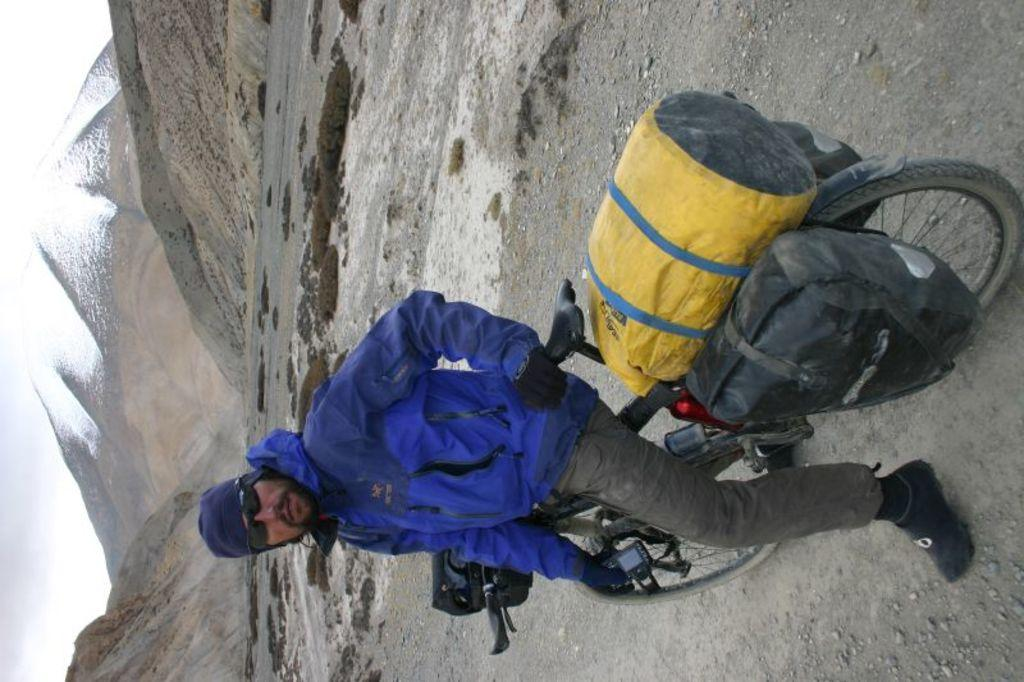Who is in the image? There is a man in the image. What is the man doing in the image? The man is sitting on a bicycle. What can be seen in the background of the image? There are hills visible in the background of the image. What part of the image contains sky? The bottom left side of the image contains sky. What decision did the man make before ending up in jail in the image? There is no indication of a man being in jail or making any decisions in the image. 